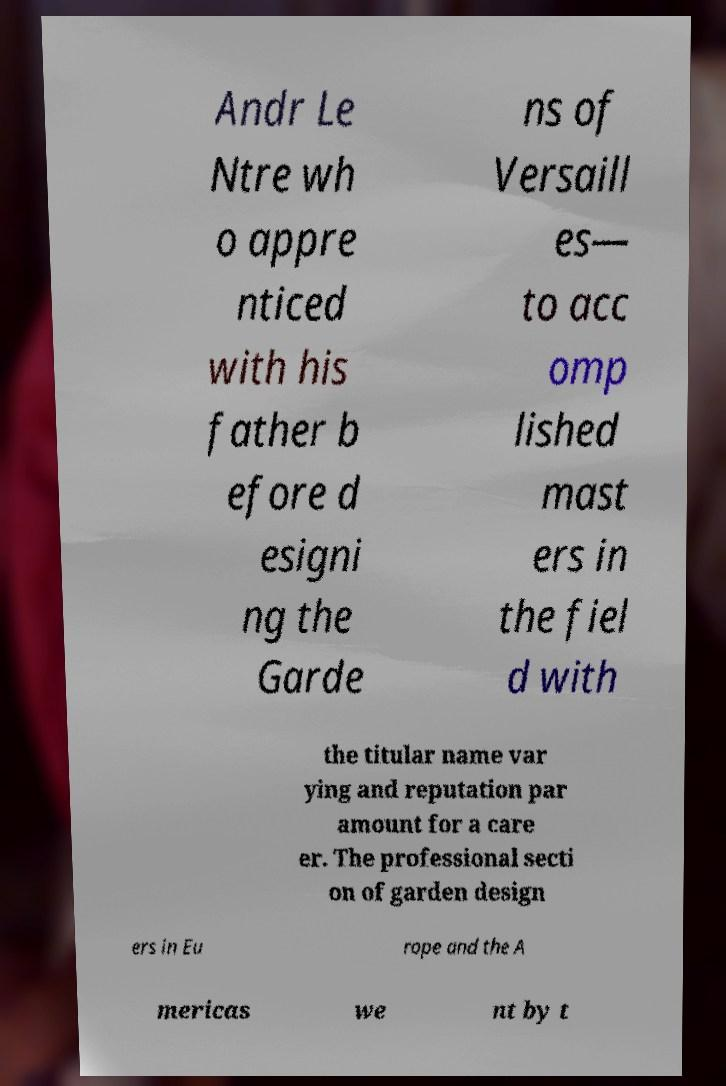Could you assist in decoding the text presented in this image and type it out clearly? Andr Le Ntre wh o appre nticed with his father b efore d esigni ng the Garde ns of Versaill es— to acc omp lished mast ers in the fiel d with the titular name var ying and reputation par amount for a care er. The professional secti on of garden design ers in Eu rope and the A mericas we nt by t 